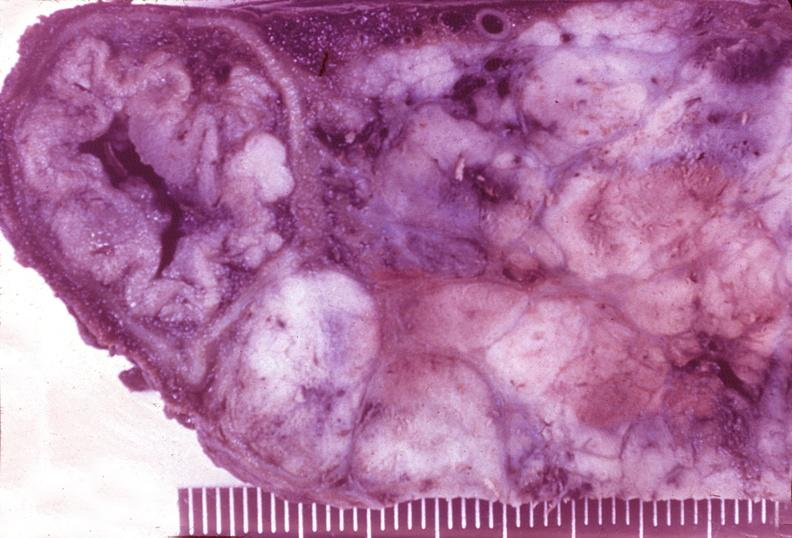does cardiovascular show islet cell carcinoma?
Answer the question using a single word or phrase. No 